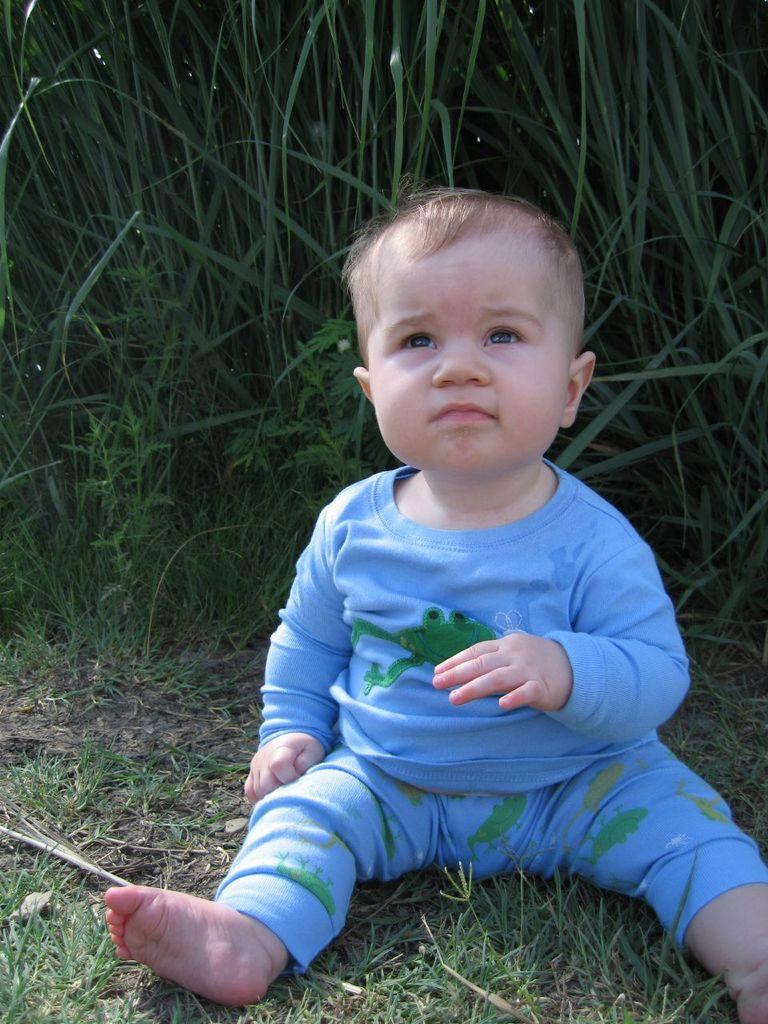What is the main subject of the image? There is a baby in the image. What is the baby wearing? The baby is wearing a blue dress. What type of environment is visible in the image? There is grass visible in the image. What other living organisms can be seen in the image? There are plants in the image. What type of group activity is the baby participating in with their elbow in the image? There is no group activity or elbow visible in the image; it features a baby wearing a blue dress in a grassy environment with plants. 